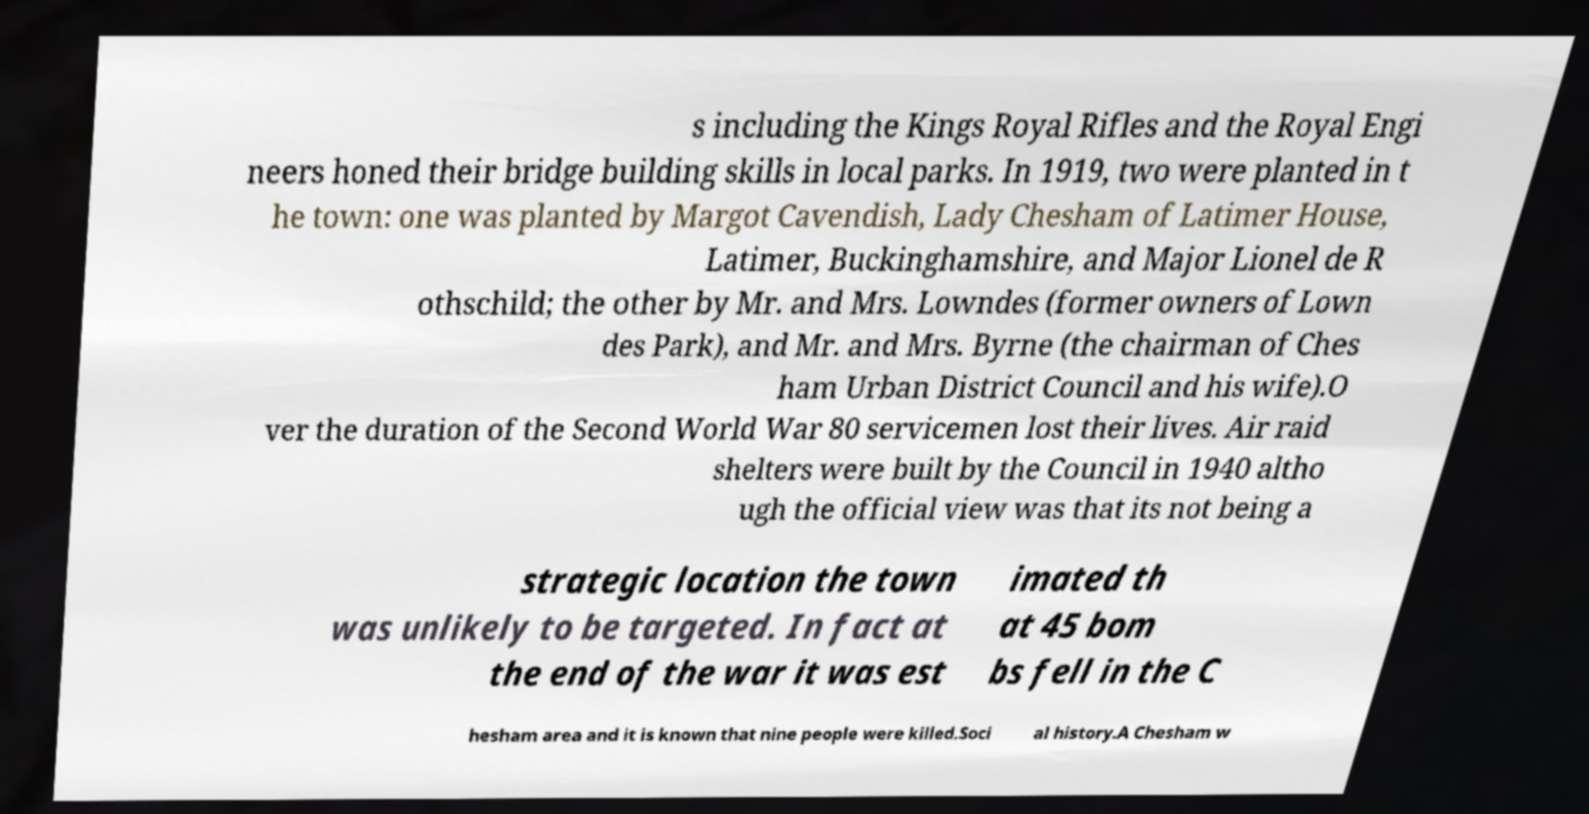Please identify and transcribe the text found in this image. s including the Kings Royal Rifles and the Royal Engi neers honed their bridge building skills in local parks. In 1919, two were planted in t he town: one was planted by Margot Cavendish, Lady Chesham of Latimer House, Latimer, Buckinghamshire, and Major Lionel de R othschild; the other by Mr. and Mrs. Lowndes (former owners of Lown des Park), and Mr. and Mrs. Byrne (the chairman of Ches ham Urban District Council and his wife).O ver the duration of the Second World War 80 servicemen lost their lives. Air raid shelters were built by the Council in 1940 altho ugh the official view was that its not being a strategic location the town was unlikely to be targeted. In fact at the end of the war it was est imated th at 45 bom bs fell in the C hesham area and it is known that nine people were killed.Soci al history.A Chesham w 